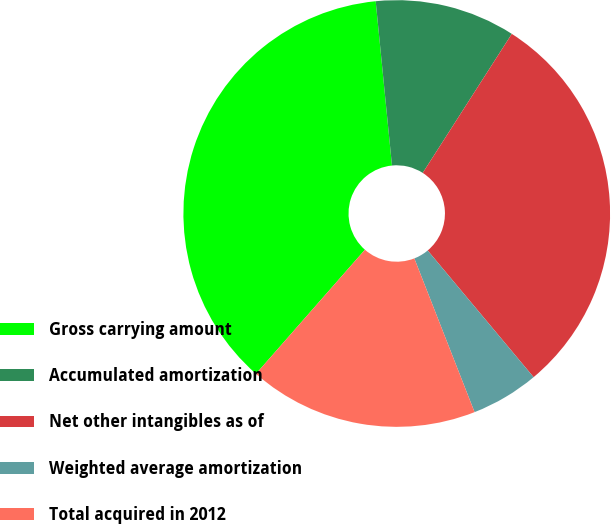Convert chart to OTSL. <chart><loc_0><loc_0><loc_500><loc_500><pie_chart><fcel>Gross carrying amount<fcel>Accumulated amortization<fcel>Net other intangibles as of<fcel>Weighted average amortization<fcel>Total acquired in 2012<nl><fcel>36.96%<fcel>10.64%<fcel>29.85%<fcel>5.14%<fcel>17.41%<nl></chart> 